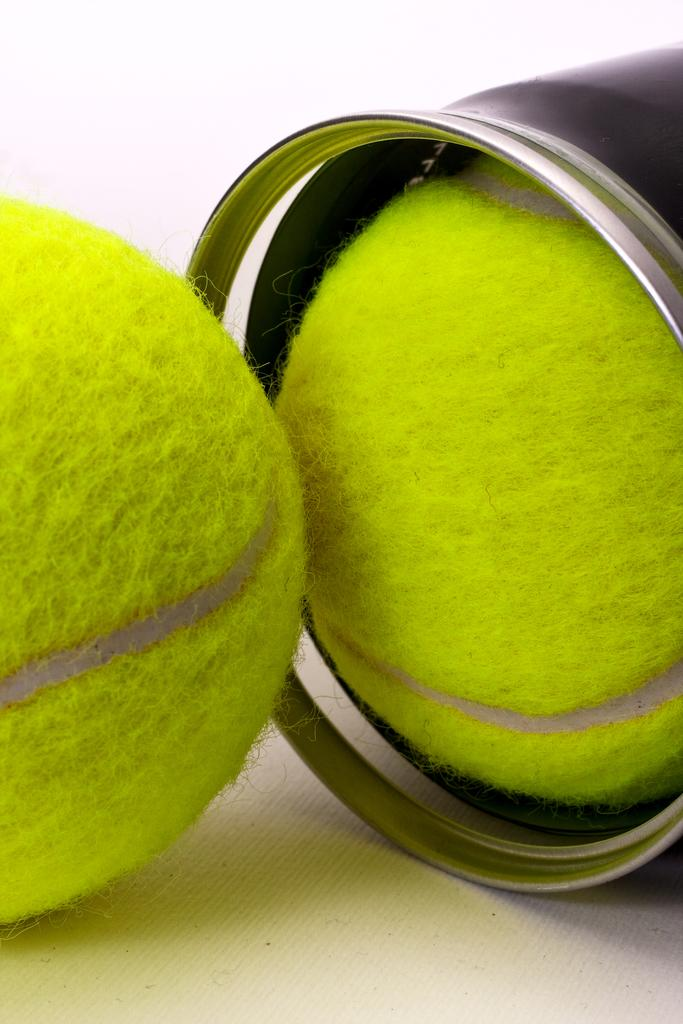What is the color of the surface in the image? The surface in the image is white. What object can be seen on the left side of the image? There is a tennis ball on the left side of the image. What object is located on the right side of the image? There is a bottle on the right side of the image. Are there any other tennis balls in the image? Yes, there is another tennis ball near the bottle on the right side of the image. How many waves can be seen in the image? There are no waves present in the image. What type of seed is growing near the tennis ball on the right side of the image? There are no seeds present in the image. 